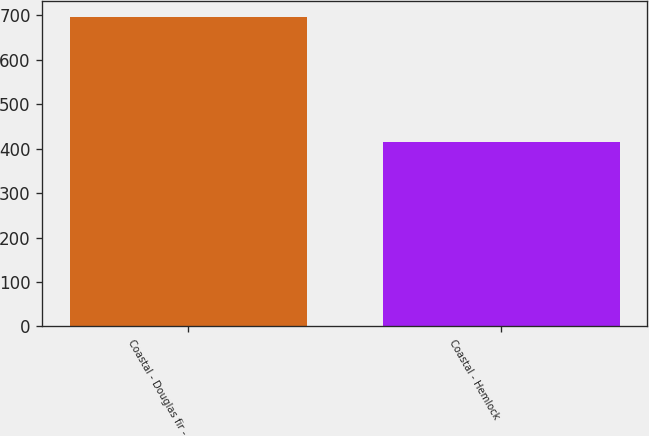<chart> <loc_0><loc_0><loc_500><loc_500><bar_chart><fcel>Coastal - Douglas fir -<fcel>Coastal - Hemlock<nl><fcel>697<fcel>416<nl></chart> 